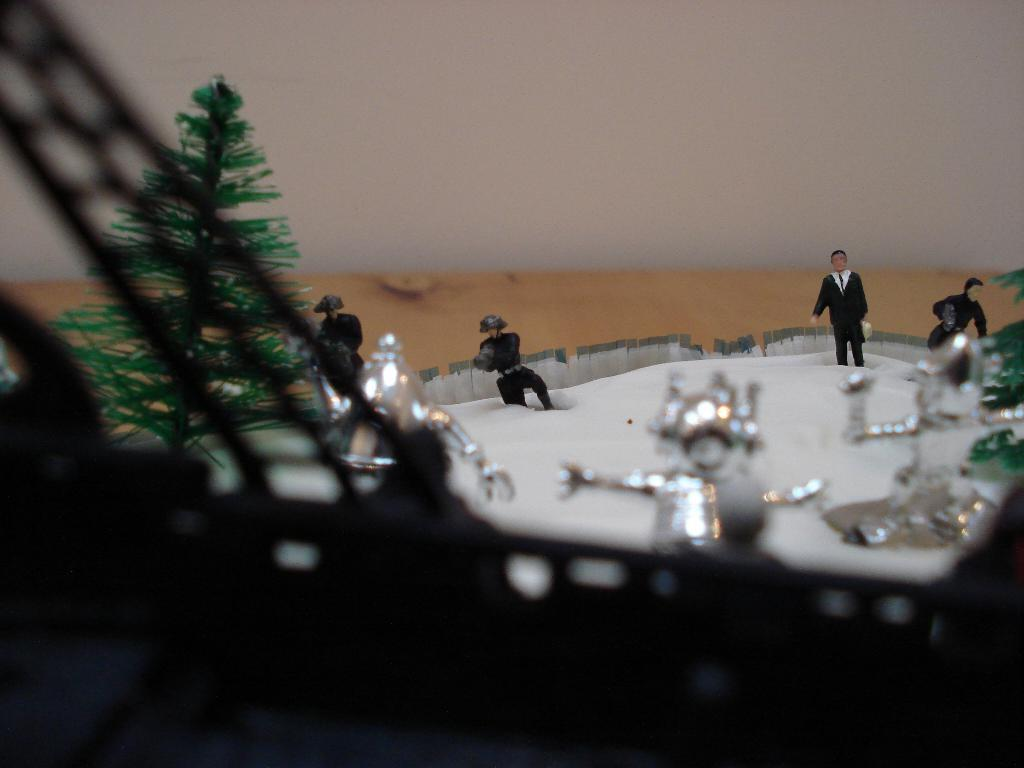What type of miniatures are present in the image? There are miniatures of trees, people, and objects in the image. Can you describe the background of the image? There is a wall in the background of the image. What type of food is being served in the image? There is no food present in the image; it features miniatures of trees, people, and objects. What experience can be gained from observing the miniatures in the image? The image is not meant to provide an experience; it is simply a collection of miniatures. 